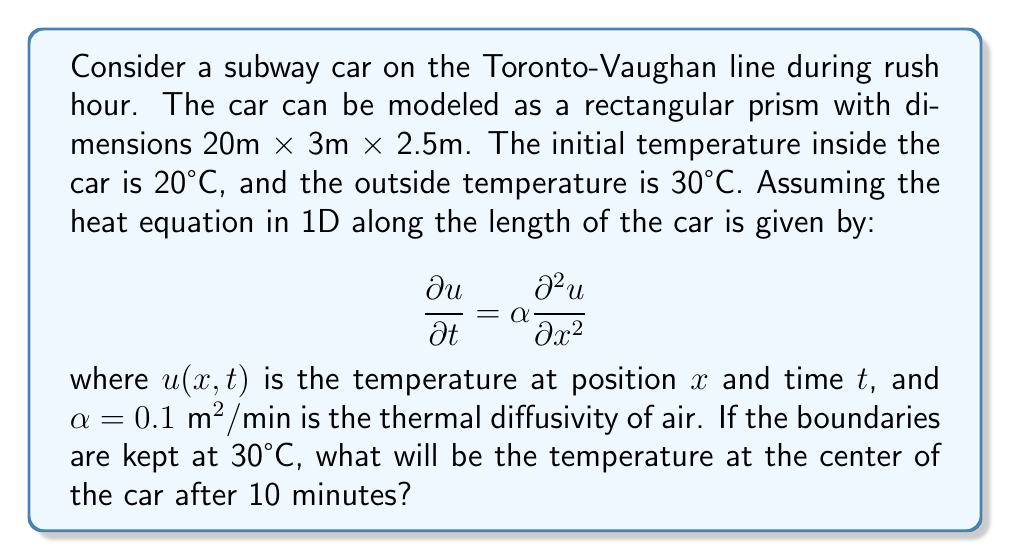Solve this math problem. To solve this problem, we need to use the solution to the 1D heat equation with Dirichlet boundary conditions. The solution is given by:

$$u(x,t) = u_0 + (u_1 - u_0)\frac{x}{L} + \frac{2}{\pi}\sum_{n=1}^{\infty} \frac{1}{n}\sin\left(\frac{n\pi x}{L}\right)e^{-\alpha n^2\pi^2t/L^2}[u_1(-1)^n - u_0]$$

Where:
- $u_0 = 20°C$ (initial temperature)
- $u_1 = 30°C$ (boundary temperature)
- $L = 20m$ (length of the car)
- $\alpha = 0.1 \text{ m}^2/\text{min}$ (thermal diffusivity)
- $t = 10 \text{ min}$ (time elapsed)
- $x = 10m$ (center of the car)

Substituting these values:

$$u(10,10) = 20 + (30 - 20)\frac{10}{20} + \frac{2}{\pi}\sum_{n=1}^{\infty} \frac{1}{n}\sin\left(\frac{n\pi 10}{20}\right)e^{-0.1 n^2\pi^2 10/20^2}[30(-1)^n - 20]$$

$$= 25 + \frac{2}{\pi}\sum_{n=1}^{\infty} \frac{1}{n}\sin\left(\frac{n\pi}{2}\right)e^{-0.025n^2\pi^2}[30(-1)^n - 20]$$

The series converges quickly, so we can approximate it by taking the first few terms. After calculation:

$$u(10,10) \approx 25.8°C$$
Answer: The temperature at the center of the subway car after 10 minutes will be approximately 25.8°C. 